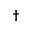Convert formula to latex. <formula><loc_0><loc_0><loc_500><loc_500>^ { \dag }</formula> 